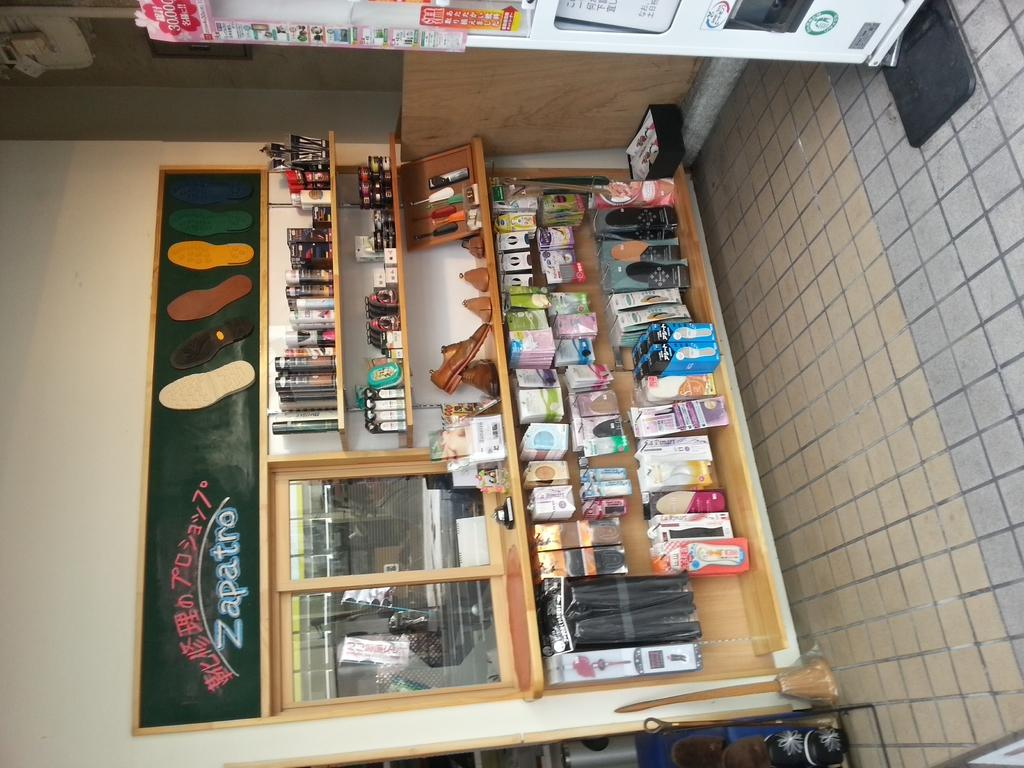<image>
Share a concise interpretation of the image provided. a shelf in a store with a chalk board above it with Zapatros on it 